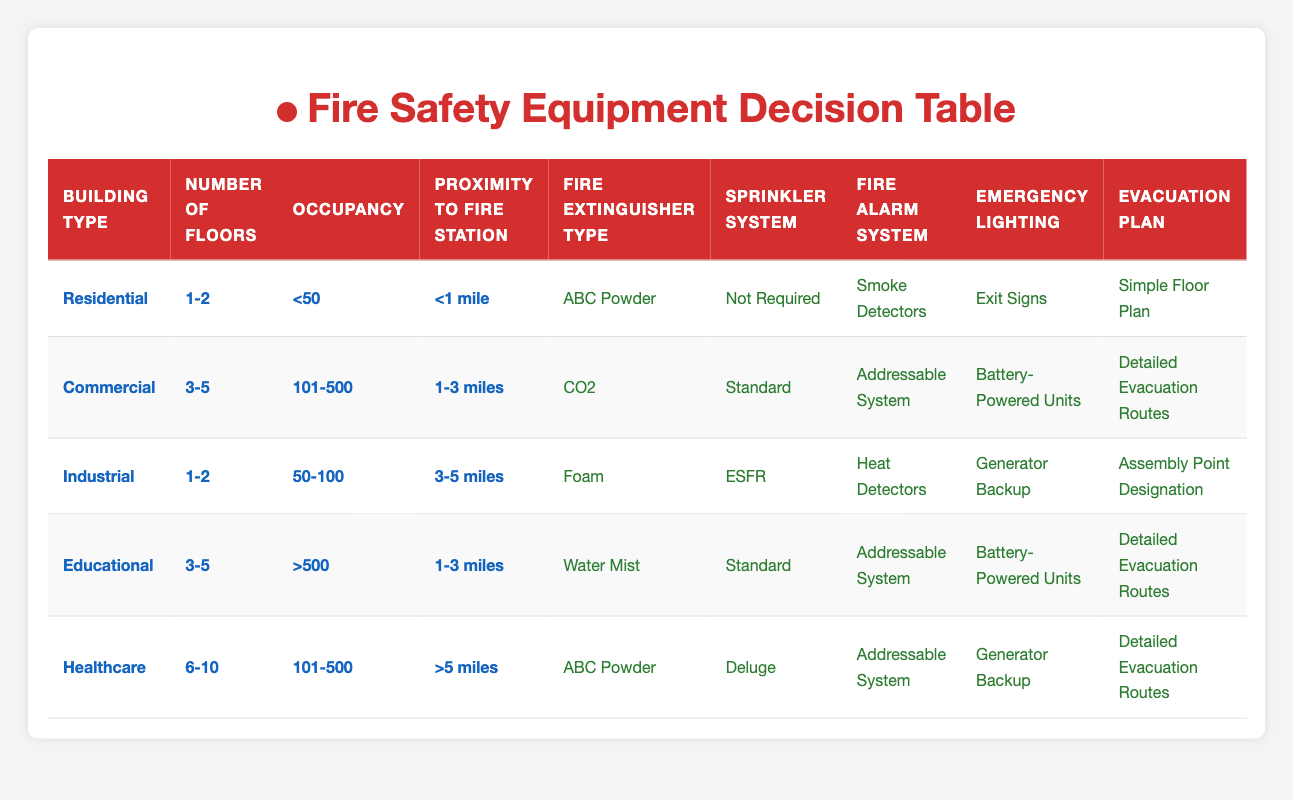What type of fire extinguisher is recommended for a Residential building with 1-2 floors and an occupancy of less than 50? According to the table, for a Residential building with 1-2 floors and an occupancy of less than 50, the recommended fire extinguisher type is ABC Powder.
Answer: ABC Powder Is a sprinkler system required for an Educational building with 3-5 floors and an occupancy of more than 500? The table shows that for an Educational building with the specified conditions, a Standard sprinkler system is required.
Answer: Yes What is the fire alarm system for an Industrial building with 1-2 floors and an occupancy of 50-100? For the Industrial building meeting those criteria, the fire alarm system indicated in the table is Heat Detectors.
Answer: Heat Detectors How many different types of fire extinguishers are used across all building types in the table? The table lists five types of fire extinguishers (ABC Powder, CO2, Foam, Water Mist, Class K). Therefore, across all building types, there are 5 different types of fire extinguishers used.
Answer: 5 For a Healthcare building with 6-10 floors and an occupancy of 101-500 located more than 5 miles from a fire station, what type of emergency lighting is recommended? The table indicates that for a Healthcare building fulfilling these conditions, the recommended emergency lighting is Generator Backup.
Answer: Generator Backup Is there a requirement for an evacuation plan in an Industrial building with 1-2 floors and an occupancy of 50-100? Yes, the table shows that an Assembly Point Designation is the evacuation plan required for this building type and conditions.
Answer: Yes Which building type requires the use of Water Mist fire extinguishers and what are its conditions? The table states that Educational buildings requiring Water Mist fire extinguishers have 3-5 floors and an occupancy of more than 500.
Answer: Educational building with 3-5 floors and occupancy >500 Among the different building types, which one has the highest occupancy and what type of fire alarm system do they use? The Educational building has the highest occupancy (>500) and uses an Addressable System for the fire alarm system.
Answer: Educational, Addressable System 